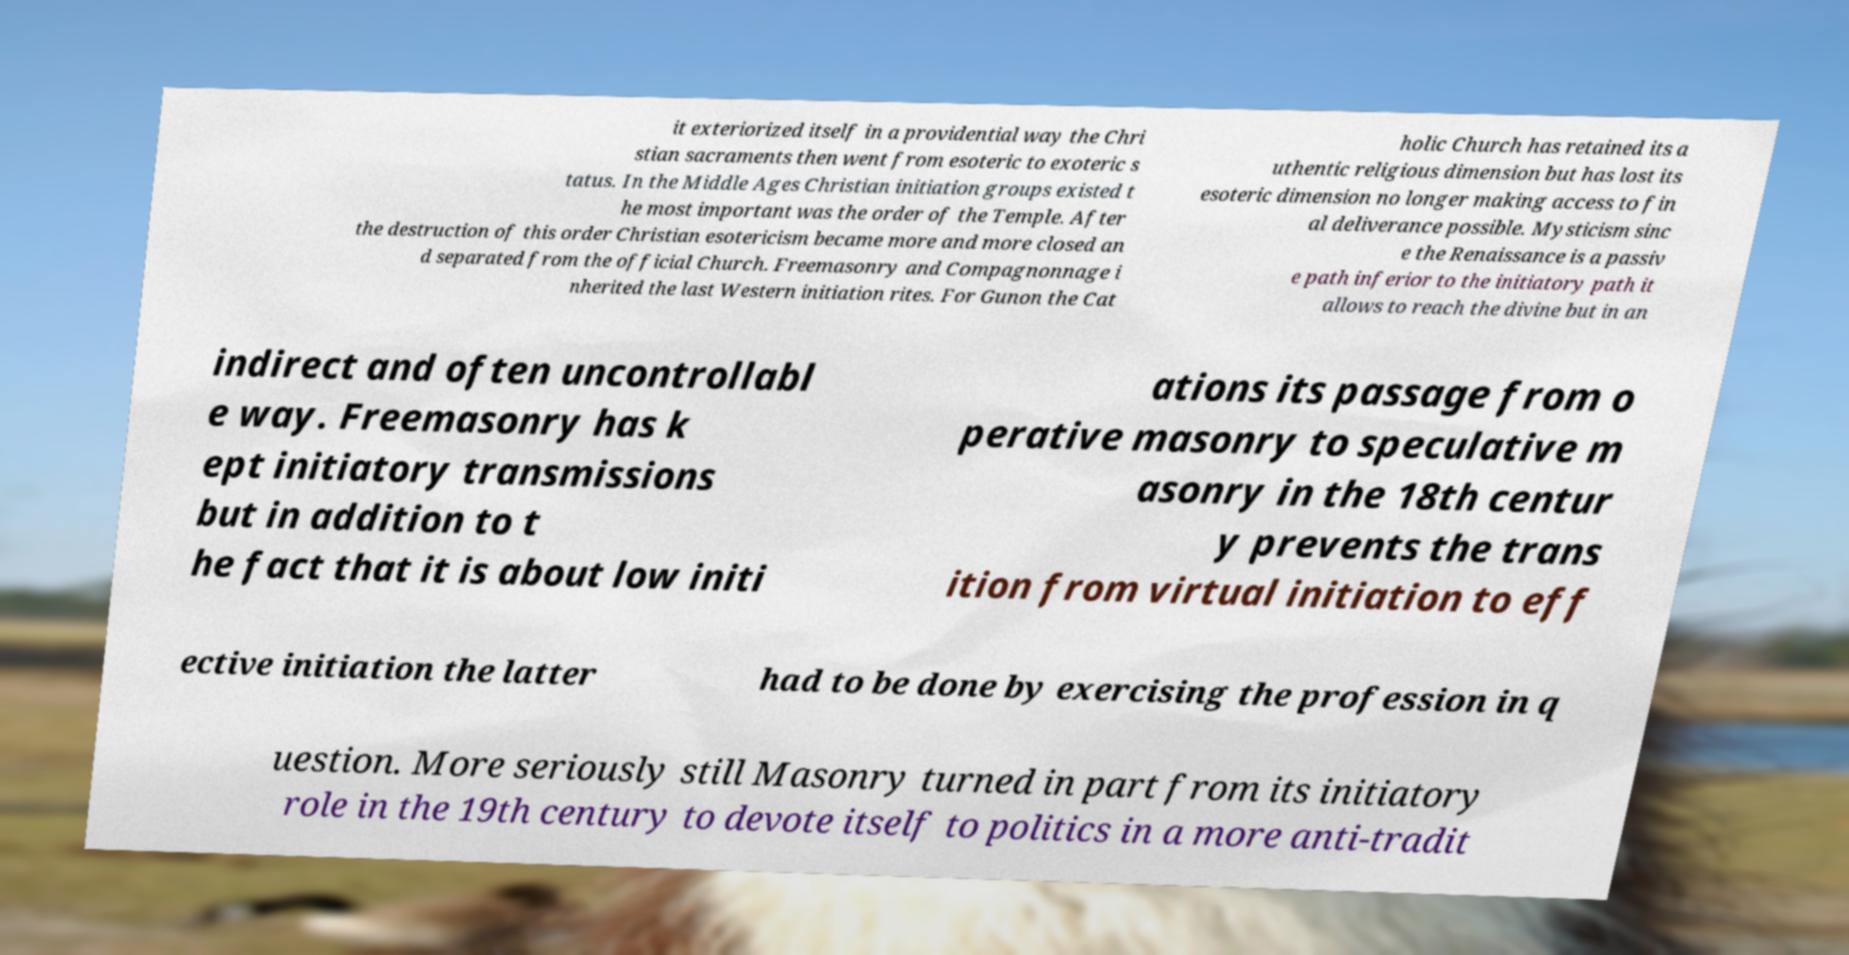Could you extract and type out the text from this image? it exteriorized itself in a providential way the Chri stian sacraments then went from esoteric to exoteric s tatus. In the Middle Ages Christian initiation groups existed t he most important was the order of the Temple. After the destruction of this order Christian esotericism became more and more closed an d separated from the official Church. Freemasonry and Compagnonnage i nherited the last Western initiation rites. For Gunon the Cat holic Church has retained its a uthentic religious dimension but has lost its esoteric dimension no longer making access to fin al deliverance possible. Mysticism sinc e the Renaissance is a passiv e path inferior to the initiatory path it allows to reach the divine but in an indirect and often uncontrollabl e way. Freemasonry has k ept initiatory transmissions but in addition to t he fact that it is about low initi ations its passage from o perative masonry to speculative m asonry in the 18th centur y prevents the trans ition from virtual initiation to eff ective initiation the latter had to be done by exercising the profession in q uestion. More seriously still Masonry turned in part from its initiatory role in the 19th century to devote itself to politics in a more anti-tradit 